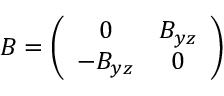Convert formula to latex. <formula><loc_0><loc_0><loc_500><loc_500>B = \left ( \begin{array} { c c } { 0 } & { { B _ { y z } } } \\ { { - B _ { y z } } } & { 0 } \end{array} \right )</formula> 